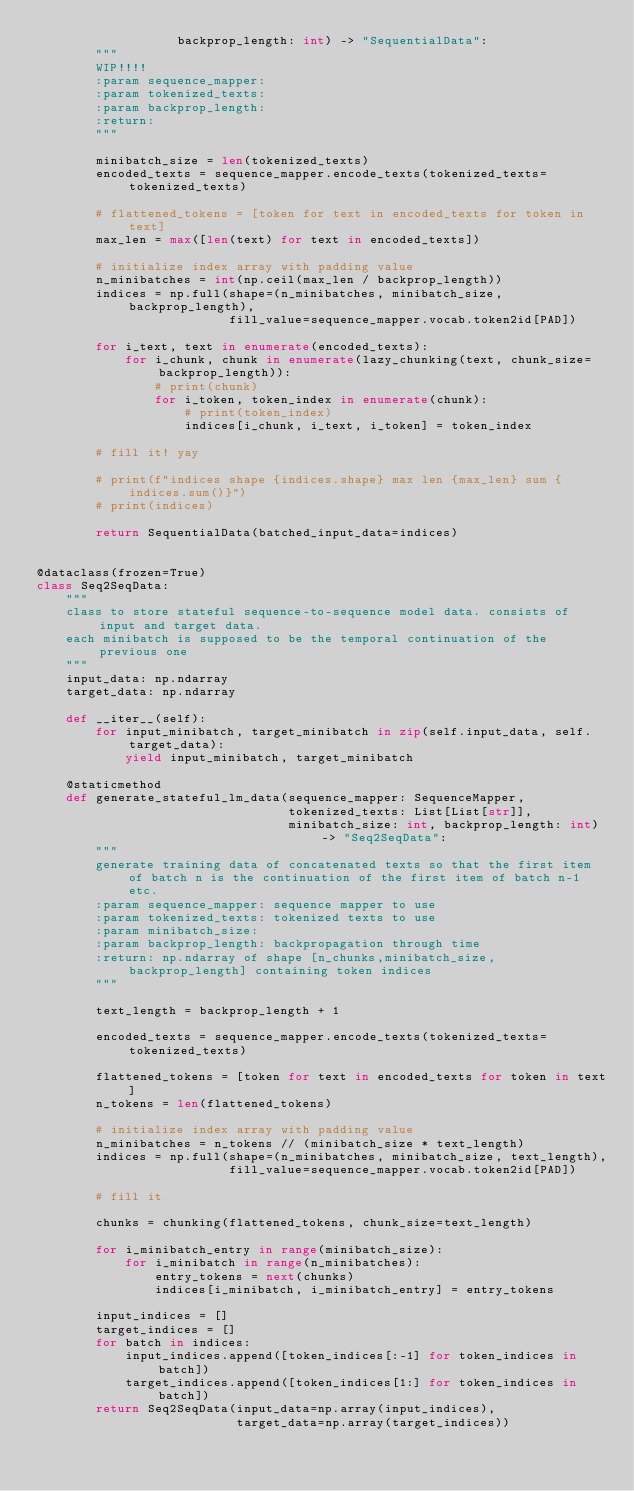<code> <loc_0><loc_0><loc_500><loc_500><_Python_>                   backprop_length: int) -> "SequentialData":
        """
        WIP!!!!
        :param sequence_mapper:
        :param tokenized_texts:
        :param backprop_length:
        :return:
        """

        minibatch_size = len(tokenized_texts)
        encoded_texts = sequence_mapper.encode_texts(tokenized_texts=tokenized_texts)

        # flattened_tokens = [token for text in encoded_texts for token in text]
        max_len = max([len(text) for text in encoded_texts])

        # initialize index array with padding value
        n_minibatches = int(np.ceil(max_len / backprop_length))
        indices = np.full(shape=(n_minibatches, minibatch_size, backprop_length),
                          fill_value=sequence_mapper.vocab.token2id[PAD])

        for i_text, text in enumerate(encoded_texts):
            for i_chunk, chunk in enumerate(lazy_chunking(text, chunk_size=backprop_length)):
                # print(chunk)
                for i_token, token_index in enumerate(chunk):
                    # print(token_index)
                    indices[i_chunk, i_text, i_token] = token_index

        # fill it! yay

        # print(f"indices shape {indices.shape} max len {max_len} sum {indices.sum()}")
        # print(indices)

        return SequentialData(batched_input_data=indices)


@dataclass(frozen=True)
class Seq2SeqData:
    """
    class to store stateful sequence-to-sequence model data. consists of input and target data.
    each minibatch is supposed to be the temporal continuation of the previous one
    """
    input_data: np.ndarray
    target_data: np.ndarray

    def __iter__(self):
        for input_minibatch, target_minibatch in zip(self.input_data, self.target_data):
            yield input_minibatch, target_minibatch

    @staticmethod
    def generate_stateful_lm_data(sequence_mapper: SequenceMapper,
                                  tokenized_texts: List[List[str]],
                                  minibatch_size: int, backprop_length: int) -> "Seq2SeqData":
        """
        generate training data of concatenated texts so that the first item of batch n is the continuation of the first item of batch n-1 etc.
        :param sequence_mapper: sequence mapper to use
        :param tokenized_texts: tokenized texts to use
        :param minibatch_size:
        :param backprop_length: backpropagation through time
        :return: np.ndarray of shape [n_chunks,minibatch_size, backprop_length] containing token indices
        """

        text_length = backprop_length + 1

        encoded_texts = sequence_mapper.encode_texts(tokenized_texts=tokenized_texts)

        flattened_tokens = [token for text in encoded_texts for token in text]
        n_tokens = len(flattened_tokens)

        # initialize index array with padding value
        n_minibatches = n_tokens // (minibatch_size * text_length)
        indices = np.full(shape=(n_minibatches, minibatch_size, text_length),
                          fill_value=sequence_mapper.vocab.token2id[PAD])

        # fill it

        chunks = chunking(flattened_tokens, chunk_size=text_length)

        for i_minibatch_entry in range(minibatch_size):
            for i_minibatch in range(n_minibatches):
                entry_tokens = next(chunks)
                indices[i_minibatch, i_minibatch_entry] = entry_tokens

        input_indices = []
        target_indices = []
        for batch in indices:
            input_indices.append([token_indices[:-1] for token_indices in batch])
            target_indices.append([token_indices[1:] for token_indices in batch])
        return Seq2SeqData(input_data=np.array(input_indices),
                           target_data=np.array(target_indices))
</code> 